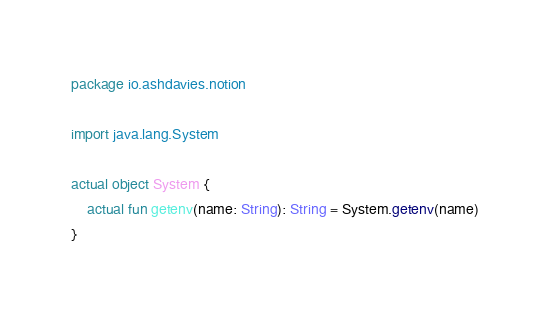Convert code to text. <code><loc_0><loc_0><loc_500><loc_500><_Kotlin_>package io.ashdavies.notion

import java.lang.System

actual object System {
    actual fun getenv(name: String): String = System.getenv(name)
}
</code> 